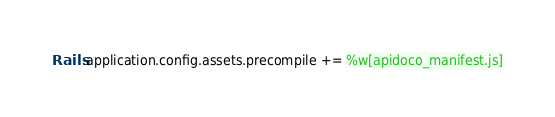<code> <loc_0><loc_0><loc_500><loc_500><_Ruby_>Rails.application.config.assets.precompile += %w[apidoco_manifest.js]
</code> 